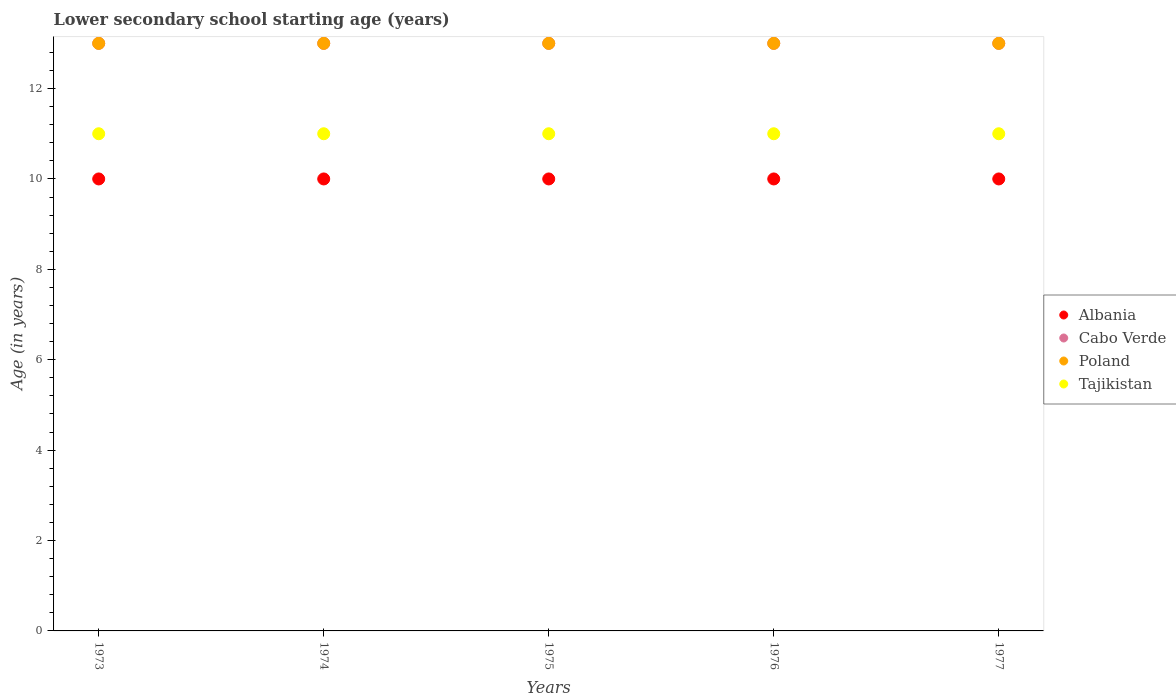How many different coloured dotlines are there?
Provide a succinct answer. 4. Is the number of dotlines equal to the number of legend labels?
Make the answer very short. Yes. What is the lower secondary school starting age of children in Cabo Verde in 1977?
Your answer should be very brief. 13. Across all years, what is the maximum lower secondary school starting age of children in Tajikistan?
Your answer should be very brief. 11. Across all years, what is the minimum lower secondary school starting age of children in Cabo Verde?
Your answer should be very brief. 13. In which year was the lower secondary school starting age of children in Poland maximum?
Make the answer very short. 1973. In which year was the lower secondary school starting age of children in Cabo Verde minimum?
Your answer should be very brief. 1973. What is the total lower secondary school starting age of children in Tajikistan in the graph?
Ensure brevity in your answer.  55. What is the difference between the lower secondary school starting age of children in Cabo Verde in 1976 and the lower secondary school starting age of children in Albania in 1977?
Your answer should be compact. 3. In the year 1977, what is the difference between the lower secondary school starting age of children in Albania and lower secondary school starting age of children in Tajikistan?
Your response must be concise. -1. In how many years, is the lower secondary school starting age of children in Albania greater than 6 years?
Your answer should be compact. 5. What is the difference between the highest and the lowest lower secondary school starting age of children in Poland?
Ensure brevity in your answer.  0. In how many years, is the lower secondary school starting age of children in Tajikistan greater than the average lower secondary school starting age of children in Tajikistan taken over all years?
Offer a terse response. 0. Does the lower secondary school starting age of children in Tajikistan monotonically increase over the years?
Offer a terse response. No. Is the lower secondary school starting age of children in Poland strictly greater than the lower secondary school starting age of children in Albania over the years?
Keep it short and to the point. Yes. How many years are there in the graph?
Your response must be concise. 5. What is the difference between two consecutive major ticks on the Y-axis?
Offer a very short reply. 2. Where does the legend appear in the graph?
Make the answer very short. Center right. How many legend labels are there?
Your answer should be very brief. 4. How are the legend labels stacked?
Provide a succinct answer. Vertical. What is the title of the graph?
Your response must be concise. Lower secondary school starting age (years). Does "Brazil" appear as one of the legend labels in the graph?
Your answer should be compact. No. What is the label or title of the Y-axis?
Provide a succinct answer. Age (in years). What is the Age (in years) in Albania in 1973?
Your answer should be compact. 10. What is the Age (in years) in Cabo Verde in 1974?
Ensure brevity in your answer.  13. What is the Age (in years) of Poland in 1974?
Your response must be concise. 13. What is the Age (in years) in Albania in 1975?
Give a very brief answer. 10. What is the Age (in years) in Cabo Verde in 1975?
Your answer should be compact. 13. What is the Age (in years) in Albania in 1976?
Provide a short and direct response. 10. What is the Age (in years) of Cabo Verde in 1976?
Provide a succinct answer. 13. What is the Age (in years) in Tajikistan in 1976?
Offer a very short reply. 11. What is the Age (in years) in Albania in 1977?
Offer a terse response. 10. Across all years, what is the maximum Age (in years) in Poland?
Your answer should be very brief. 13. Across all years, what is the minimum Age (in years) in Albania?
Keep it short and to the point. 10. Across all years, what is the minimum Age (in years) in Cabo Verde?
Offer a very short reply. 13. What is the total Age (in years) of Poland in the graph?
Give a very brief answer. 65. What is the total Age (in years) in Tajikistan in the graph?
Make the answer very short. 55. What is the difference between the Age (in years) of Albania in 1973 and that in 1974?
Offer a very short reply. 0. What is the difference between the Age (in years) of Cabo Verde in 1973 and that in 1974?
Give a very brief answer. 0. What is the difference between the Age (in years) of Tajikistan in 1973 and that in 1974?
Your response must be concise. 0. What is the difference between the Age (in years) in Albania in 1973 and that in 1975?
Your answer should be very brief. 0. What is the difference between the Age (in years) in Poland in 1973 and that in 1975?
Offer a terse response. 0. What is the difference between the Age (in years) of Albania in 1973 and that in 1976?
Your answer should be very brief. 0. What is the difference between the Age (in years) of Cabo Verde in 1973 and that in 1976?
Give a very brief answer. 0. What is the difference between the Age (in years) in Tajikistan in 1973 and that in 1976?
Your answer should be compact. 0. What is the difference between the Age (in years) in Albania in 1973 and that in 1977?
Offer a terse response. 0. What is the difference between the Age (in years) in Cabo Verde in 1973 and that in 1977?
Your answer should be very brief. 0. What is the difference between the Age (in years) in Albania in 1974 and that in 1975?
Offer a very short reply. 0. What is the difference between the Age (in years) in Cabo Verde in 1974 and that in 1975?
Offer a terse response. 0. What is the difference between the Age (in years) of Tajikistan in 1974 and that in 1975?
Provide a succinct answer. 0. What is the difference between the Age (in years) in Cabo Verde in 1974 and that in 1977?
Your answer should be compact. 0. What is the difference between the Age (in years) in Poland in 1974 and that in 1977?
Offer a very short reply. 0. What is the difference between the Age (in years) in Tajikistan in 1975 and that in 1976?
Your response must be concise. 0. What is the difference between the Age (in years) of Albania in 1975 and that in 1977?
Provide a short and direct response. 0. What is the difference between the Age (in years) in Cabo Verde in 1975 and that in 1977?
Keep it short and to the point. 0. What is the difference between the Age (in years) of Cabo Verde in 1976 and that in 1977?
Your response must be concise. 0. What is the difference between the Age (in years) in Poland in 1976 and that in 1977?
Ensure brevity in your answer.  0. What is the difference between the Age (in years) in Tajikistan in 1976 and that in 1977?
Make the answer very short. 0. What is the difference between the Age (in years) in Albania in 1973 and the Age (in years) in Tajikistan in 1974?
Ensure brevity in your answer.  -1. What is the difference between the Age (in years) in Cabo Verde in 1973 and the Age (in years) in Poland in 1974?
Ensure brevity in your answer.  0. What is the difference between the Age (in years) in Cabo Verde in 1973 and the Age (in years) in Poland in 1975?
Your response must be concise. 0. What is the difference between the Age (in years) of Cabo Verde in 1973 and the Age (in years) of Tajikistan in 1975?
Your answer should be very brief. 2. What is the difference between the Age (in years) in Poland in 1973 and the Age (in years) in Tajikistan in 1975?
Give a very brief answer. 2. What is the difference between the Age (in years) in Albania in 1973 and the Age (in years) in Cabo Verde in 1976?
Keep it short and to the point. -3. What is the difference between the Age (in years) of Albania in 1973 and the Age (in years) of Poland in 1976?
Make the answer very short. -3. What is the difference between the Age (in years) of Albania in 1973 and the Age (in years) of Poland in 1977?
Offer a very short reply. -3. What is the difference between the Age (in years) of Albania in 1973 and the Age (in years) of Tajikistan in 1977?
Your response must be concise. -1. What is the difference between the Age (in years) in Cabo Verde in 1973 and the Age (in years) in Poland in 1977?
Ensure brevity in your answer.  0. What is the difference between the Age (in years) in Cabo Verde in 1973 and the Age (in years) in Tajikistan in 1977?
Your answer should be compact. 2. What is the difference between the Age (in years) of Poland in 1974 and the Age (in years) of Tajikistan in 1975?
Offer a very short reply. 2. What is the difference between the Age (in years) of Albania in 1974 and the Age (in years) of Poland in 1976?
Ensure brevity in your answer.  -3. What is the difference between the Age (in years) in Cabo Verde in 1974 and the Age (in years) in Poland in 1976?
Ensure brevity in your answer.  0. What is the difference between the Age (in years) of Cabo Verde in 1974 and the Age (in years) of Tajikistan in 1976?
Keep it short and to the point. 2. What is the difference between the Age (in years) in Cabo Verde in 1974 and the Age (in years) in Tajikistan in 1977?
Offer a terse response. 2. What is the difference between the Age (in years) of Poland in 1974 and the Age (in years) of Tajikistan in 1977?
Give a very brief answer. 2. What is the difference between the Age (in years) of Albania in 1975 and the Age (in years) of Cabo Verde in 1976?
Provide a short and direct response. -3. What is the difference between the Age (in years) in Albania in 1975 and the Age (in years) in Poland in 1976?
Make the answer very short. -3. What is the difference between the Age (in years) of Albania in 1975 and the Age (in years) of Tajikistan in 1976?
Your answer should be compact. -1. What is the difference between the Age (in years) of Poland in 1975 and the Age (in years) of Tajikistan in 1976?
Your answer should be compact. 2. What is the difference between the Age (in years) of Albania in 1975 and the Age (in years) of Poland in 1977?
Your response must be concise. -3. What is the difference between the Age (in years) in Cabo Verde in 1975 and the Age (in years) in Poland in 1977?
Keep it short and to the point. 0. What is the difference between the Age (in years) of Albania in 1976 and the Age (in years) of Cabo Verde in 1977?
Provide a succinct answer. -3. What is the average Age (in years) of Cabo Verde per year?
Give a very brief answer. 13. What is the average Age (in years) of Poland per year?
Your response must be concise. 13. In the year 1973, what is the difference between the Age (in years) of Albania and Age (in years) of Cabo Verde?
Offer a terse response. -3. In the year 1973, what is the difference between the Age (in years) of Albania and Age (in years) of Poland?
Your response must be concise. -3. In the year 1973, what is the difference between the Age (in years) in Cabo Verde and Age (in years) in Poland?
Make the answer very short. 0. In the year 1973, what is the difference between the Age (in years) in Cabo Verde and Age (in years) in Tajikistan?
Your response must be concise. 2. In the year 1973, what is the difference between the Age (in years) in Poland and Age (in years) in Tajikistan?
Provide a short and direct response. 2. In the year 1974, what is the difference between the Age (in years) of Albania and Age (in years) of Cabo Verde?
Your response must be concise. -3. In the year 1974, what is the difference between the Age (in years) in Albania and Age (in years) in Tajikistan?
Your answer should be very brief. -1. In the year 1975, what is the difference between the Age (in years) in Albania and Age (in years) in Cabo Verde?
Offer a terse response. -3. In the year 1975, what is the difference between the Age (in years) in Cabo Verde and Age (in years) in Poland?
Your answer should be compact. 0. In the year 1975, what is the difference between the Age (in years) in Cabo Verde and Age (in years) in Tajikistan?
Your answer should be compact. 2. In the year 1975, what is the difference between the Age (in years) of Poland and Age (in years) of Tajikistan?
Your answer should be very brief. 2. In the year 1976, what is the difference between the Age (in years) of Albania and Age (in years) of Cabo Verde?
Ensure brevity in your answer.  -3. In the year 1976, what is the difference between the Age (in years) of Albania and Age (in years) of Tajikistan?
Offer a very short reply. -1. In the year 1976, what is the difference between the Age (in years) in Cabo Verde and Age (in years) in Poland?
Keep it short and to the point. 0. In the year 1976, what is the difference between the Age (in years) in Cabo Verde and Age (in years) in Tajikistan?
Offer a very short reply. 2. In the year 1976, what is the difference between the Age (in years) of Poland and Age (in years) of Tajikistan?
Your answer should be very brief. 2. In the year 1977, what is the difference between the Age (in years) of Albania and Age (in years) of Cabo Verde?
Your answer should be compact. -3. In the year 1977, what is the difference between the Age (in years) of Albania and Age (in years) of Tajikistan?
Your answer should be very brief. -1. In the year 1977, what is the difference between the Age (in years) of Cabo Verde and Age (in years) of Poland?
Offer a very short reply. 0. What is the ratio of the Age (in years) of Albania in 1973 to that in 1974?
Your answer should be compact. 1. What is the ratio of the Age (in years) in Poland in 1973 to that in 1974?
Make the answer very short. 1. What is the ratio of the Age (in years) in Tajikistan in 1973 to that in 1975?
Provide a succinct answer. 1. What is the ratio of the Age (in years) of Albania in 1973 to that in 1976?
Offer a terse response. 1. What is the ratio of the Age (in years) of Tajikistan in 1973 to that in 1976?
Ensure brevity in your answer.  1. What is the ratio of the Age (in years) of Tajikistan in 1973 to that in 1977?
Offer a very short reply. 1. What is the ratio of the Age (in years) in Albania in 1974 to that in 1975?
Ensure brevity in your answer.  1. What is the ratio of the Age (in years) in Poland in 1974 to that in 1975?
Offer a terse response. 1. What is the ratio of the Age (in years) in Cabo Verde in 1974 to that in 1976?
Provide a short and direct response. 1. What is the ratio of the Age (in years) in Poland in 1974 to that in 1976?
Ensure brevity in your answer.  1. What is the ratio of the Age (in years) in Albania in 1974 to that in 1977?
Provide a short and direct response. 1. What is the ratio of the Age (in years) of Cabo Verde in 1974 to that in 1977?
Provide a short and direct response. 1. What is the ratio of the Age (in years) of Albania in 1975 to that in 1976?
Your answer should be very brief. 1. What is the ratio of the Age (in years) of Poland in 1975 to that in 1976?
Your answer should be very brief. 1. What is the ratio of the Age (in years) of Tajikistan in 1975 to that in 1976?
Your response must be concise. 1. What is the ratio of the Age (in years) in Albania in 1975 to that in 1977?
Provide a succinct answer. 1. What is the ratio of the Age (in years) of Cabo Verde in 1975 to that in 1977?
Give a very brief answer. 1. What is the ratio of the Age (in years) in Albania in 1976 to that in 1977?
Keep it short and to the point. 1. What is the ratio of the Age (in years) in Poland in 1976 to that in 1977?
Your answer should be compact. 1. What is the difference between the highest and the second highest Age (in years) of Poland?
Give a very brief answer. 0. What is the difference between the highest and the second highest Age (in years) in Tajikistan?
Provide a succinct answer. 0. What is the difference between the highest and the lowest Age (in years) of Albania?
Give a very brief answer. 0. What is the difference between the highest and the lowest Age (in years) of Cabo Verde?
Ensure brevity in your answer.  0. What is the difference between the highest and the lowest Age (in years) in Poland?
Give a very brief answer. 0. What is the difference between the highest and the lowest Age (in years) of Tajikistan?
Keep it short and to the point. 0. 